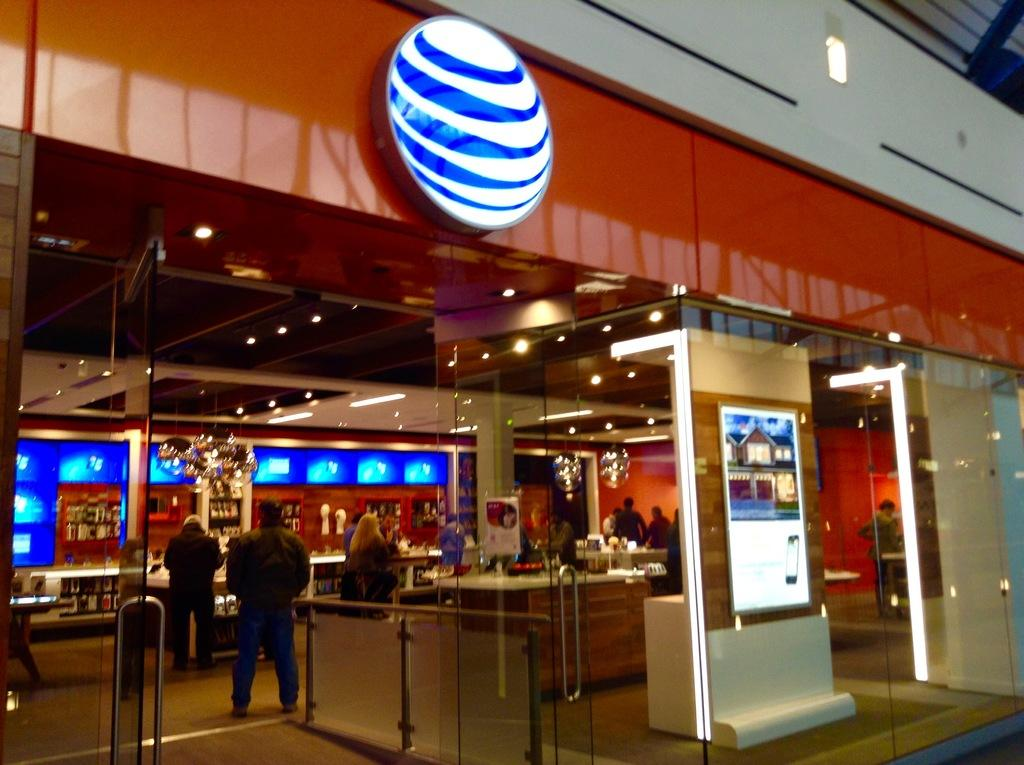What type of location is depicted in the image? A: The image is an inside view of a building. What can be seen in the image that provides illumination? There are lights in the image. What type of architectural feature is present in the image? There are glass doors in the image. What type of electronic devices are visible in the image? There are screens in the image. What type of containers are present in the image? There are bottles in the image. What type of decorative or functional items are present in the image? There are frames in the image. What type of surface is visible in the image? There is a floor in the image. What type of furniture is present in the image? There are tables in the image. What type of structural support is present in the image? There is a pillar in the image. How many toes are visible in the image? There are no visible toes in the image, as it is an inside view of a building and does not show any people or body parts. 